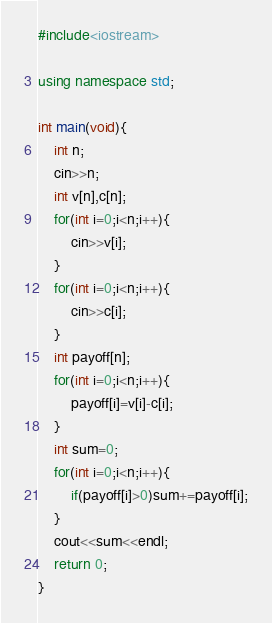<code> <loc_0><loc_0><loc_500><loc_500><_C++_>#include<iostream>

using namespace std;

int main(void){
    int n;
    cin>>n;
    int v[n],c[n];
    for(int i=0;i<n;i++){
        cin>>v[i];
    }
    for(int i=0;i<n;i++){
        cin>>c[i];
    }
    int payoff[n];
    for(int i=0;i<n;i++){
        payoff[i]=v[i]-c[i];
    }
    int sum=0;
    for(int i=0;i<n;i++){
        if(payoff[i]>0)sum+=payoff[i];
    }
    cout<<sum<<endl;
    return 0;
}</code> 